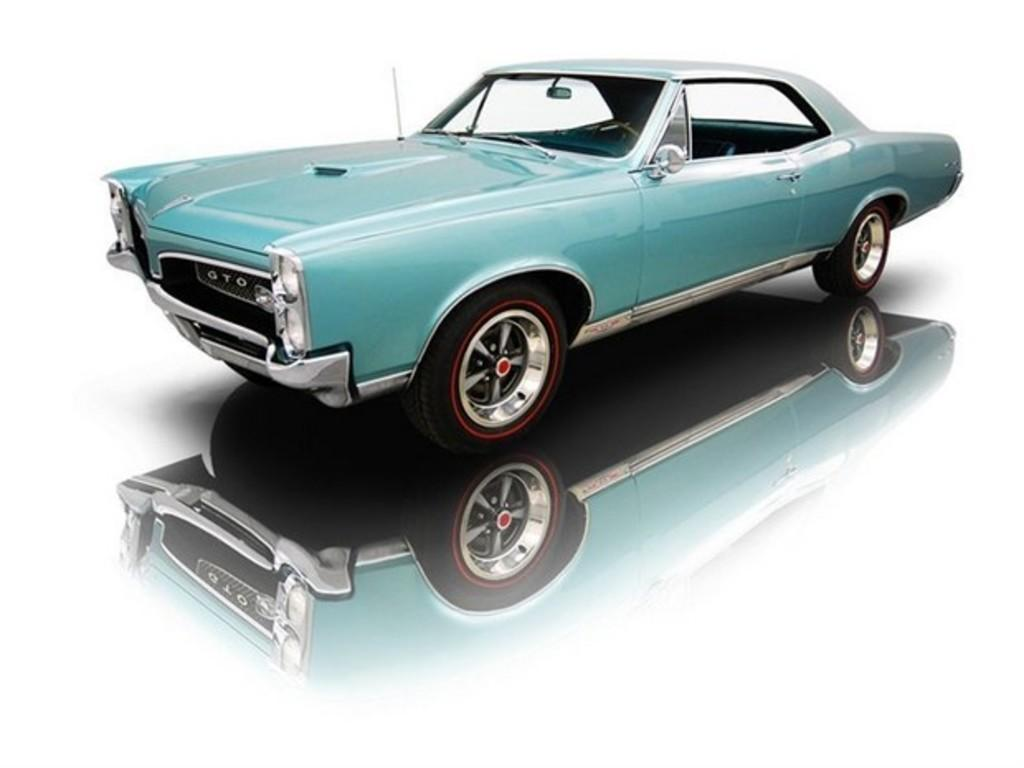What is the main subject of the image? The main subject of the image is a car. Can you describe the color of the car? The car is blue. What color is the background of the image? The background of the image is white. What type of treatment is the car receiving in the image? There is no indication in the image that the car is receiving any treatment. 